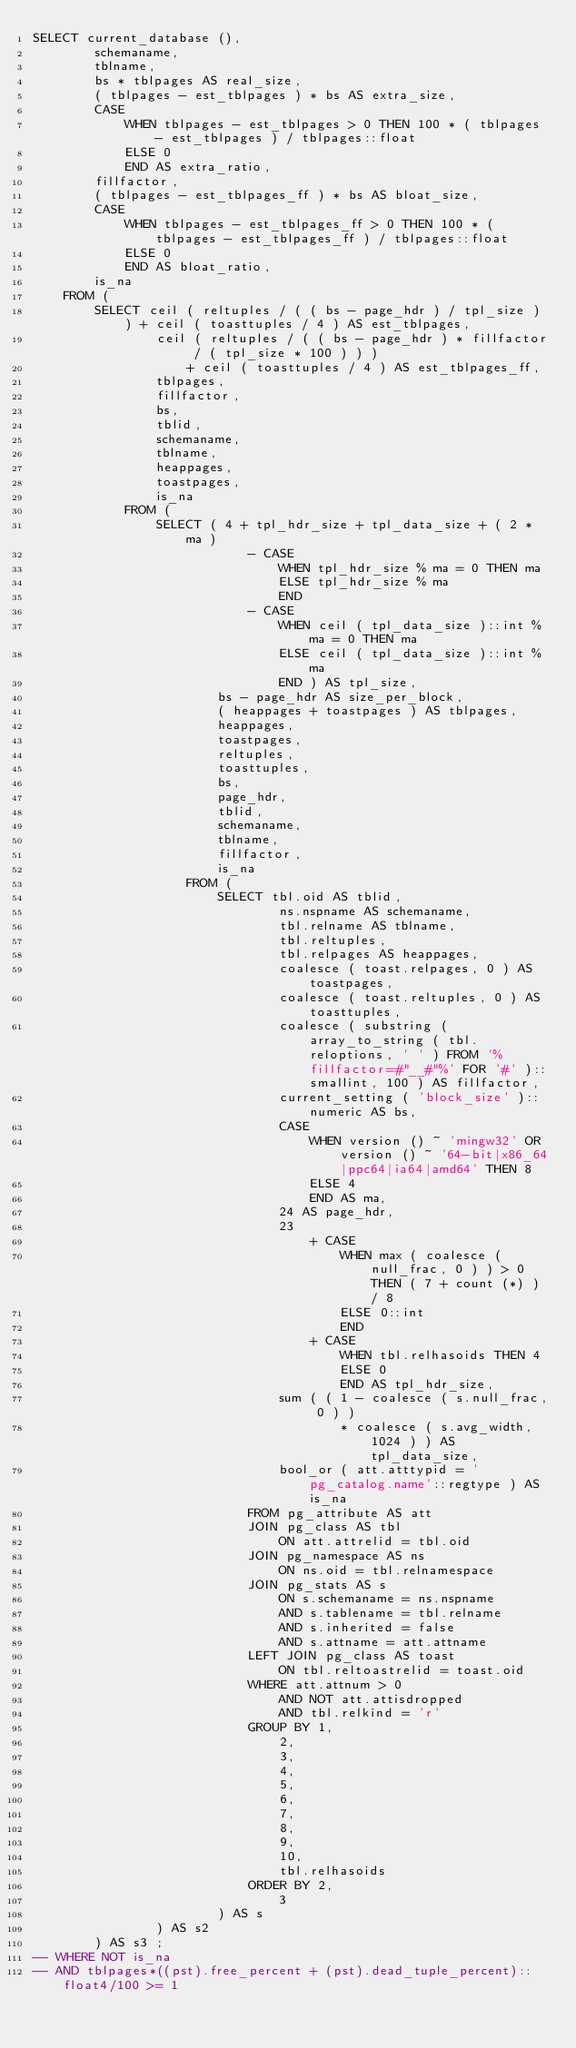Convert code to text. <code><loc_0><loc_0><loc_500><loc_500><_SQL_>SELECT current_database (),
        schemaname,
        tblname,
        bs * tblpages AS real_size,
        ( tblpages - est_tblpages ) * bs AS extra_size,
        CASE
            WHEN tblpages - est_tblpages > 0 THEN 100 * ( tblpages - est_tblpages ) / tblpages::float
            ELSE 0
            END AS extra_ratio,
        fillfactor,
        ( tblpages - est_tblpages_ff ) * bs AS bloat_size,
        CASE
            WHEN tblpages - est_tblpages_ff > 0 THEN 100 * ( tblpages - est_tblpages_ff ) / tblpages::float
            ELSE 0
            END AS bloat_ratio,
        is_na
    FROM (
        SELECT ceil ( reltuples / ( ( bs - page_hdr ) / tpl_size ) ) + ceil ( toasttuples / 4 ) AS est_tblpages,
                ceil ( reltuples / ( ( bs - page_hdr ) * fillfactor / ( tpl_size * 100 ) ) )
                    + ceil ( toasttuples / 4 ) AS est_tblpages_ff,
                tblpages,
                fillfactor,
                bs,
                tblid,
                schemaname,
                tblname,
                heappages,
                toastpages,
                is_na
            FROM (
                SELECT ( 4 + tpl_hdr_size + tpl_data_size + ( 2 * ma )
                            - CASE
                                WHEN tpl_hdr_size % ma = 0 THEN ma
                                ELSE tpl_hdr_size % ma
                                END
                            - CASE
                                WHEN ceil ( tpl_data_size )::int % ma = 0 THEN ma
                                ELSE ceil ( tpl_data_size )::int % ma
                                END ) AS tpl_size,
                        bs - page_hdr AS size_per_block,
                        ( heappages + toastpages ) AS tblpages,
                        heappages,
                        toastpages,
                        reltuples,
                        toasttuples,
                        bs,
                        page_hdr,
                        tblid,
                        schemaname,
                        tblname,
                        fillfactor,
                        is_na
                    FROM (
                        SELECT tbl.oid AS tblid,
                                ns.nspname AS schemaname,
                                tbl.relname AS tblname,
                                tbl.reltuples,
                                tbl.relpages AS heappages,
                                coalesce ( toast.relpages, 0 ) AS toastpages,
                                coalesce ( toast.reltuples, 0 ) AS toasttuples,
                                coalesce ( substring ( array_to_string ( tbl.reloptions, ' ' ) FROM '%fillfactor=#"__#"%' FOR '#' )::smallint, 100 ) AS fillfactor,
                                current_setting ( 'block_size' )::numeric AS bs,
                                CASE
                                    WHEN version () ~ 'mingw32' OR version () ~ '64-bit|x86_64|ppc64|ia64|amd64' THEN 8
                                    ELSE 4
                                    END AS ma,
                                24 AS page_hdr,
                                23
                                    + CASE
                                        WHEN max ( coalesce ( null_frac, 0 ) ) > 0 THEN ( 7 + count (*) ) / 8
                                        ELSE 0::int
                                        END
                                    + CASE
                                        WHEN tbl.relhasoids THEN 4
                                        ELSE 0
                                        END AS tpl_hdr_size,
                                sum ( ( 1 - coalesce ( s.null_frac, 0 ) )
                                        * coalesce ( s.avg_width, 1024 ) ) AS tpl_data_size,
                                bool_or ( att.atttypid = 'pg_catalog.name'::regtype ) AS is_na
                            FROM pg_attribute AS att
                            JOIN pg_class AS tbl
                                ON att.attrelid = tbl.oid
                            JOIN pg_namespace AS ns
                                ON ns.oid = tbl.relnamespace
                            JOIN pg_stats AS s
                                ON s.schemaname = ns.nspname
                                AND s.tablename = tbl.relname
                                AND s.inherited = false
                                AND s.attname = att.attname
                            LEFT JOIN pg_class AS toast
                                ON tbl.reltoastrelid = toast.oid
                            WHERE att.attnum > 0
                                AND NOT att.attisdropped
                                AND tbl.relkind = 'r'
                            GROUP BY 1,
                                2,
                                3,
                                4,
                                5,
                                6,
                                7,
                                8,
                                9,
                                10,
                                tbl.relhasoids
                            ORDER BY 2,
                                3
                        ) AS s
                ) AS s2
        ) AS s3 ;
-- WHERE NOT is_na
-- AND tblpages*((pst).free_percent + (pst).dead_tuple_percent)::float4/100 >= 1

</code> 